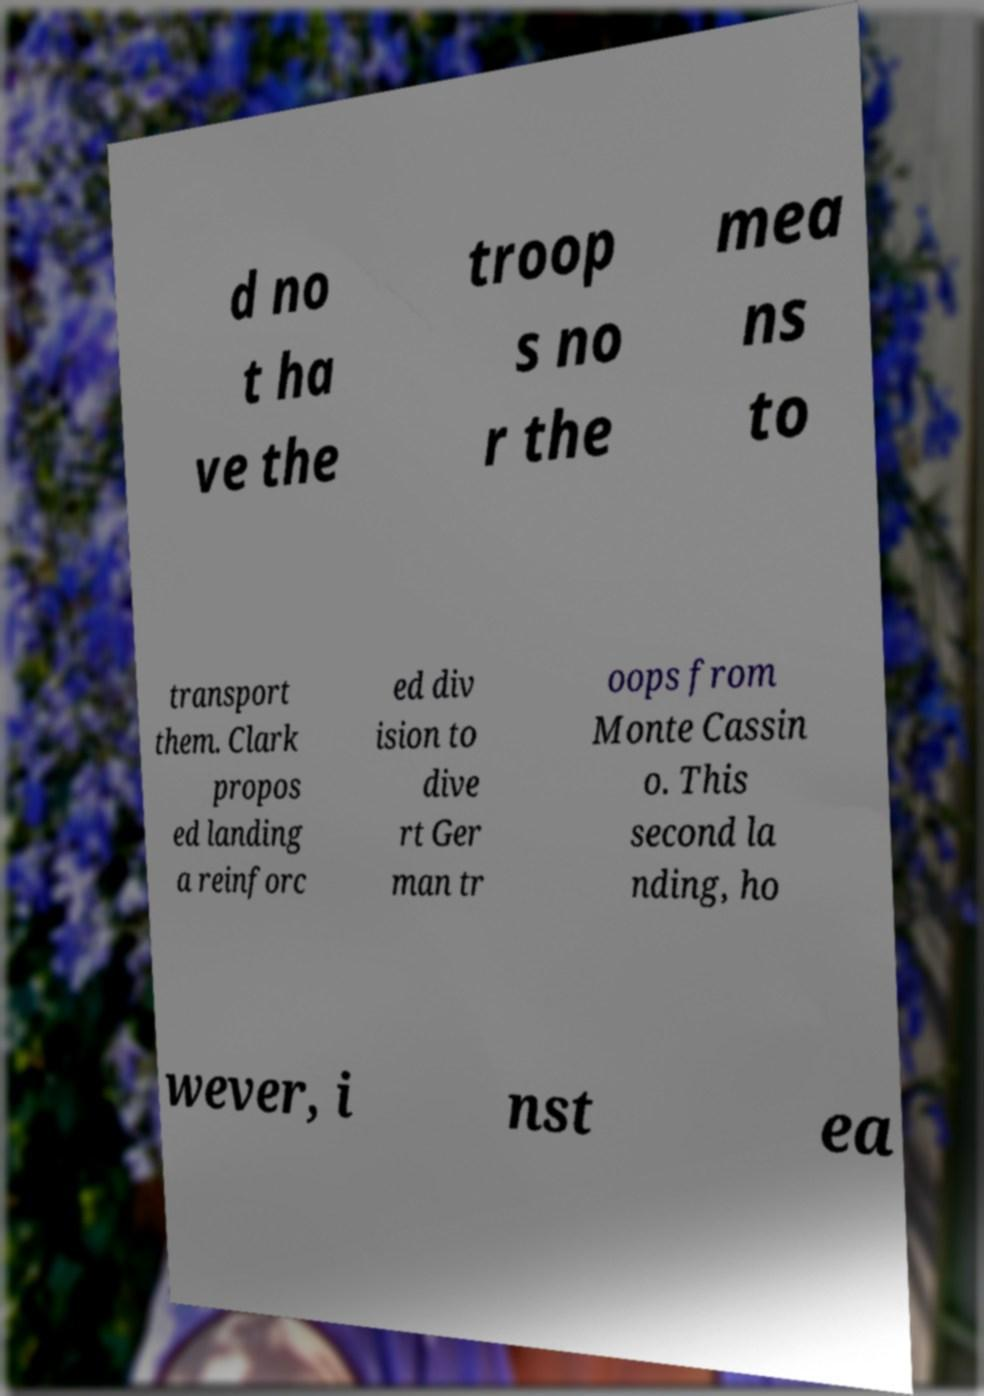Can you read and provide the text displayed in the image?This photo seems to have some interesting text. Can you extract and type it out for me? d no t ha ve the troop s no r the mea ns to transport them. Clark propos ed landing a reinforc ed div ision to dive rt Ger man tr oops from Monte Cassin o. This second la nding, ho wever, i nst ea 